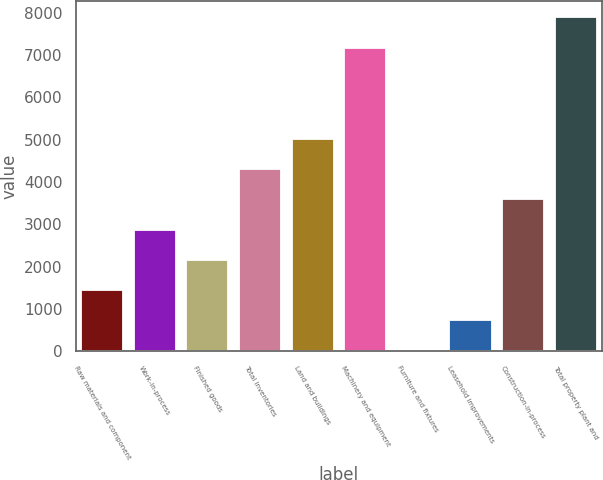Convert chart. <chart><loc_0><loc_0><loc_500><loc_500><bar_chart><fcel>Raw materials and component<fcel>Work-in-process<fcel>Finished goods<fcel>Total inventories<fcel>Land and buildings<fcel>Machinery and equipment<fcel>Furniture and fixtures<fcel>Leasehold improvements<fcel>Construction-in-process<fcel>Total property plant and<nl><fcel>1446.6<fcel>2878.2<fcel>2162.4<fcel>4309.8<fcel>5025.6<fcel>7173<fcel>15<fcel>730.8<fcel>3594<fcel>7888.8<nl></chart> 